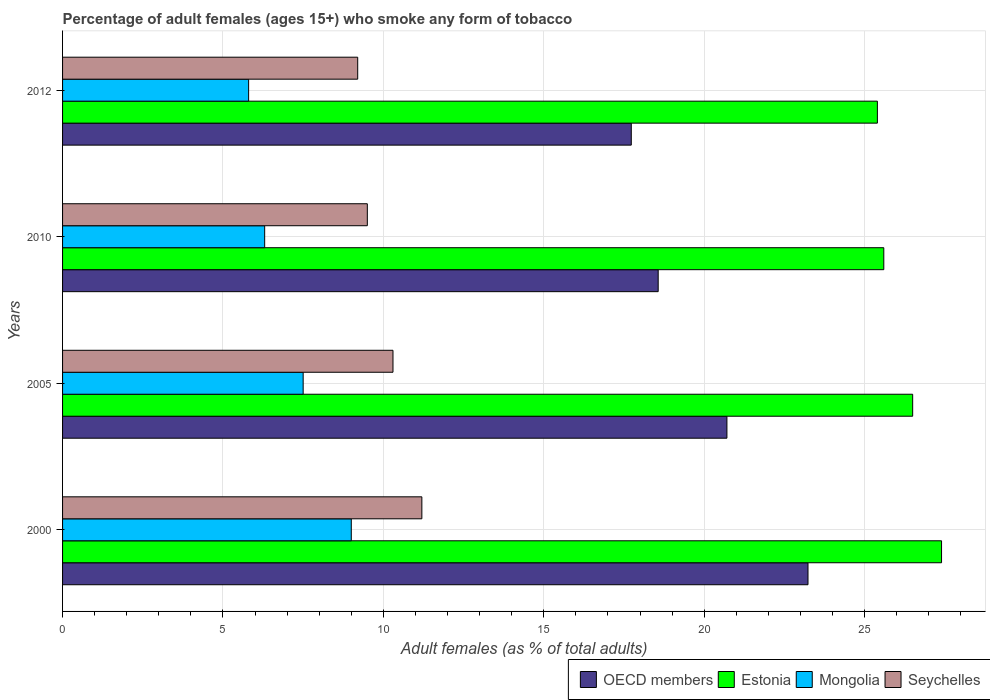How many different coloured bars are there?
Make the answer very short. 4. Are the number of bars on each tick of the Y-axis equal?
Your answer should be compact. Yes. How many bars are there on the 2nd tick from the top?
Your response must be concise. 4. What is the percentage of adult females who smoke in OECD members in 2012?
Your answer should be compact. 17.73. Across all years, what is the maximum percentage of adult females who smoke in OECD members?
Keep it short and to the point. 23.24. In which year was the percentage of adult females who smoke in Mongolia maximum?
Ensure brevity in your answer.  2000. What is the total percentage of adult females who smoke in Mongolia in the graph?
Your response must be concise. 28.6. What is the difference between the percentage of adult females who smoke in Estonia in 2005 and that in 2010?
Offer a terse response. 0.9. What is the average percentage of adult females who smoke in Mongolia per year?
Your response must be concise. 7.15. In the year 2010, what is the difference between the percentage of adult females who smoke in Seychelles and percentage of adult females who smoke in Estonia?
Provide a short and direct response. -16.1. What is the ratio of the percentage of adult females who smoke in OECD members in 2000 to that in 2010?
Your response must be concise. 1.25. Is the percentage of adult females who smoke in OECD members in 2000 less than that in 2012?
Provide a short and direct response. No. Is the difference between the percentage of adult females who smoke in Seychelles in 2000 and 2005 greater than the difference between the percentage of adult females who smoke in Estonia in 2000 and 2005?
Offer a terse response. No. What is the difference between the highest and the second highest percentage of adult females who smoke in OECD members?
Provide a succinct answer. 2.53. What is the difference between the highest and the lowest percentage of adult females who smoke in Estonia?
Offer a terse response. 2. In how many years, is the percentage of adult females who smoke in Mongolia greater than the average percentage of adult females who smoke in Mongolia taken over all years?
Provide a short and direct response. 2. What does the 2nd bar from the top in 2005 represents?
Offer a terse response. Mongolia. What does the 2nd bar from the bottom in 2010 represents?
Your answer should be compact. Estonia. Is it the case that in every year, the sum of the percentage of adult females who smoke in Mongolia and percentage of adult females who smoke in Seychelles is greater than the percentage of adult females who smoke in OECD members?
Give a very brief answer. No. How many bars are there?
Provide a short and direct response. 16. Are all the bars in the graph horizontal?
Give a very brief answer. Yes. How many years are there in the graph?
Give a very brief answer. 4. Are the values on the major ticks of X-axis written in scientific E-notation?
Your answer should be very brief. No. Does the graph contain grids?
Make the answer very short. Yes. How many legend labels are there?
Offer a very short reply. 4. What is the title of the graph?
Give a very brief answer. Percentage of adult females (ages 15+) who smoke any form of tobacco. Does "Uzbekistan" appear as one of the legend labels in the graph?
Provide a short and direct response. No. What is the label or title of the X-axis?
Provide a short and direct response. Adult females (as % of total adults). What is the Adult females (as % of total adults) in OECD members in 2000?
Offer a terse response. 23.24. What is the Adult females (as % of total adults) of Estonia in 2000?
Offer a very short reply. 27.4. What is the Adult females (as % of total adults) of Mongolia in 2000?
Your answer should be compact. 9. What is the Adult females (as % of total adults) in OECD members in 2005?
Provide a succinct answer. 20.71. What is the Adult females (as % of total adults) in Mongolia in 2005?
Offer a terse response. 7.5. What is the Adult females (as % of total adults) in Seychelles in 2005?
Ensure brevity in your answer.  10.3. What is the Adult females (as % of total adults) of OECD members in 2010?
Your answer should be very brief. 18.57. What is the Adult females (as % of total adults) in Estonia in 2010?
Offer a very short reply. 25.6. What is the Adult females (as % of total adults) in Mongolia in 2010?
Your answer should be compact. 6.3. What is the Adult females (as % of total adults) of OECD members in 2012?
Offer a very short reply. 17.73. What is the Adult females (as % of total adults) in Estonia in 2012?
Provide a succinct answer. 25.4. What is the Adult females (as % of total adults) of Mongolia in 2012?
Provide a succinct answer. 5.8. What is the Adult females (as % of total adults) of Seychelles in 2012?
Provide a succinct answer. 9.2. Across all years, what is the maximum Adult females (as % of total adults) in OECD members?
Your answer should be compact. 23.24. Across all years, what is the maximum Adult females (as % of total adults) of Estonia?
Offer a terse response. 27.4. Across all years, what is the maximum Adult females (as % of total adults) of Mongolia?
Your answer should be compact. 9. Across all years, what is the maximum Adult females (as % of total adults) of Seychelles?
Offer a terse response. 11.2. Across all years, what is the minimum Adult females (as % of total adults) in OECD members?
Keep it short and to the point. 17.73. Across all years, what is the minimum Adult females (as % of total adults) of Estonia?
Your answer should be very brief. 25.4. What is the total Adult females (as % of total adults) of OECD members in the graph?
Make the answer very short. 80.24. What is the total Adult females (as % of total adults) of Estonia in the graph?
Your answer should be compact. 104.9. What is the total Adult females (as % of total adults) in Mongolia in the graph?
Keep it short and to the point. 28.6. What is the total Adult females (as % of total adults) of Seychelles in the graph?
Your response must be concise. 40.2. What is the difference between the Adult females (as % of total adults) in OECD members in 2000 and that in 2005?
Ensure brevity in your answer.  2.53. What is the difference between the Adult females (as % of total adults) in Mongolia in 2000 and that in 2005?
Offer a terse response. 1.5. What is the difference between the Adult females (as % of total adults) in OECD members in 2000 and that in 2010?
Offer a very short reply. 4.67. What is the difference between the Adult females (as % of total adults) in Seychelles in 2000 and that in 2010?
Provide a succinct answer. 1.7. What is the difference between the Adult females (as % of total adults) of OECD members in 2000 and that in 2012?
Ensure brevity in your answer.  5.51. What is the difference between the Adult females (as % of total adults) of Seychelles in 2000 and that in 2012?
Give a very brief answer. 2. What is the difference between the Adult females (as % of total adults) of OECD members in 2005 and that in 2010?
Provide a short and direct response. 2.14. What is the difference between the Adult females (as % of total adults) in Mongolia in 2005 and that in 2010?
Give a very brief answer. 1.2. What is the difference between the Adult females (as % of total adults) in OECD members in 2005 and that in 2012?
Ensure brevity in your answer.  2.98. What is the difference between the Adult females (as % of total adults) in Seychelles in 2005 and that in 2012?
Keep it short and to the point. 1.1. What is the difference between the Adult females (as % of total adults) of OECD members in 2010 and that in 2012?
Ensure brevity in your answer.  0.84. What is the difference between the Adult females (as % of total adults) in Seychelles in 2010 and that in 2012?
Offer a very short reply. 0.3. What is the difference between the Adult females (as % of total adults) in OECD members in 2000 and the Adult females (as % of total adults) in Estonia in 2005?
Provide a succinct answer. -3.26. What is the difference between the Adult females (as % of total adults) of OECD members in 2000 and the Adult females (as % of total adults) of Mongolia in 2005?
Give a very brief answer. 15.74. What is the difference between the Adult females (as % of total adults) in OECD members in 2000 and the Adult females (as % of total adults) in Seychelles in 2005?
Your answer should be compact. 12.94. What is the difference between the Adult females (as % of total adults) of Estonia in 2000 and the Adult females (as % of total adults) of Mongolia in 2005?
Make the answer very short. 19.9. What is the difference between the Adult females (as % of total adults) of Estonia in 2000 and the Adult females (as % of total adults) of Seychelles in 2005?
Offer a terse response. 17.1. What is the difference between the Adult females (as % of total adults) in Mongolia in 2000 and the Adult females (as % of total adults) in Seychelles in 2005?
Provide a succinct answer. -1.3. What is the difference between the Adult females (as % of total adults) in OECD members in 2000 and the Adult females (as % of total adults) in Estonia in 2010?
Provide a succinct answer. -2.36. What is the difference between the Adult females (as % of total adults) of OECD members in 2000 and the Adult females (as % of total adults) of Mongolia in 2010?
Provide a succinct answer. 16.94. What is the difference between the Adult females (as % of total adults) of OECD members in 2000 and the Adult females (as % of total adults) of Seychelles in 2010?
Keep it short and to the point. 13.74. What is the difference between the Adult females (as % of total adults) in Estonia in 2000 and the Adult females (as % of total adults) in Mongolia in 2010?
Your answer should be compact. 21.1. What is the difference between the Adult females (as % of total adults) of Estonia in 2000 and the Adult females (as % of total adults) of Seychelles in 2010?
Offer a terse response. 17.9. What is the difference between the Adult females (as % of total adults) in Mongolia in 2000 and the Adult females (as % of total adults) in Seychelles in 2010?
Ensure brevity in your answer.  -0.5. What is the difference between the Adult females (as % of total adults) of OECD members in 2000 and the Adult females (as % of total adults) of Estonia in 2012?
Give a very brief answer. -2.16. What is the difference between the Adult females (as % of total adults) of OECD members in 2000 and the Adult females (as % of total adults) of Mongolia in 2012?
Provide a short and direct response. 17.44. What is the difference between the Adult females (as % of total adults) of OECD members in 2000 and the Adult females (as % of total adults) of Seychelles in 2012?
Make the answer very short. 14.04. What is the difference between the Adult females (as % of total adults) in Estonia in 2000 and the Adult females (as % of total adults) in Mongolia in 2012?
Your response must be concise. 21.6. What is the difference between the Adult females (as % of total adults) of Estonia in 2000 and the Adult females (as % of total adults) of Seychelles in 2012?
Offer a very short reply. 18.2. What is the difference between the Adult females (as % of total adults) in Mongolia in 2000 and the Adult females (as % of total adults) in Seychelles in 2012?
Make the answer very short. -0.2. What is the difference between the Adult females (as % of total adults) in OECD members in 2005 and the Adult females (as % of total adults) in Estonia in 2010?
Ensure brevity in your answer.  -4.89. What is the difference between the Adult females (as % of total adults) of OECD members in 2005 and the Adult females (as % of total adults) of Mongolia in 2010?
Provide a short and direct response. 14.41. What is the difference between the Adult females (as % of total adults) of OECD members in 2005 and the Adult females (as % of total adults) of Seychelles in 2010?
Give a very brief answer. 11.21. What is the difference between the Adult females (as % of total adults) in Estonia in 2005 and the Adult females (as % of total adults) in Mongolia in 2010?
Your answer should be very brief. 20.2. What is the difference between the Adult females (as % of total adults) of Mongolia in 2005 and the Adult females (as % of total adults) of Seychelles in 2010?
Provide a short and direct response. -2. What is the difference between the Adult females (as % of total adults) of OECD members in 2005 and the Adult females (as % of total adults) of Estonia in 2012?
Ensure brevity in your answer.  -4.69. What is the difference between the Adult females (as % of total adults) in OECD members in 2005 and the Adult females (as % of total adults) in Mongolia in 2012?
Keep it short and to the point. 14.91. What is the difference between the Adult females (as % of total adults) in OECD members in 2005 and the Adult females (as % of total adults) in Seychelles in 2012?
Your response must be concise. 11.51. What is the difference between the Adult females (as % of total adults) of Estonia in 2005 and the Adult females (as % of total adults) of Mongolia in 2012?
Provide a short and direct response. 20.7. What is the difference between the Adult females (as % of total adults) in Mongolia in 2005 and the Adult females (as % of total adults) in Seychelles in 2012?
Provide a short and direct response. -1.7. What is the difference between the Adult females (as % of total adults) in OECD members in 2010 and the Adult females (as % of total adults) in Estonia in 2012?
Give a very brief answer. -6.83. What is the difference between the Adult females (as % of total adults) of OECD members in 2010 and the Adult females (as % of total adults) of Mongolia in 2012?
Keep it short and to the point. 12.77. What is the difference between the Adult females (as % of total adults) in OECD members in 2010 and the Adult females (as % of total adults) in Seychelles in 2012?
Offer a terse response. 9.37. What is the difference between the Adult females (as % of total adults) of Estonia in 2010 and the Adult females (as % of total adults) of Mongolia in 2012?
Provide a short and direct response. 19.8. What is the difference between the Adult females (as % of total adults) in Estonia in 2010 and the Adult females (as % of total adults) in Seychelles in 2012?
Offer a terse response. 16.4. What is the average Adult females (as % of total adults) of OECD members per year?
Your answer should be compact. 20.06. What is the average Adult females (as % of total adults) of Estonia per year?
Ensure brevity in your answer.  26.23. What is the average Adult females (as % of total adults) of Mongolia per year?
Keep it short and to the point. 7.15. What is the average Adult females (as % of total adults) in Seychelles per year?
Keep it short and to the point. 10.05. In the year 2000, what is the difference between the Adult females (as % of total adults) in OECD members and Adult females (as % of total adults) in Estonia?
Ensure brevity in your answer.  -4.16. In the year 2000, what is the difference between the Adult females (as % of total adults) of OECD members and Adult females (as % of total adults) of Mongolia?
Ensure brevity in your answer.  14.24. In the year 2000, what is the difference between the Adult females (as % of total adults) in OECD members and Adult females (as % of total adults) in Seychelles?
Provide a succinct answer. 12.04. In the year 2000, what is the difference between the Adult females (as % of total adults) in Estonia and Adult females (as % of total adults) in Seychelles?
Your answer should be very brief. 16.2. In the year 2005, what is the difference between the Adult females (as % of total adults) in OECD members and Adult females (as % of total adults) in Estonia?
Your answer should be very brief. -5.79. In the year 2005, what is the difference between the Adult females (as % of total adults) in OECD members and Adult females (as % of total adults) in Mongolia?
Provide a succinct answer. 13.21. In the year 2005, what is the difference between the Adult females (as % of total adults) in OECD members and Adult females (as % of total adults) in Seychelles?
Your answer should be compact. 10.41. In the year 2005, what is the difference between the Adult females (as % of total adults) of Estonia and Adult females (as % of total adults) of Mongolia?
Provide a succinct answer. 19. In the year 2005, what is the difference between the Adult females (as % of total adults) in Estonia and Adult females (as % of total adults) in Seychelles?
Offer a terse response. 16.2. In the year 2010, what is the difference between the Adult females (as % of total adults) of OECD members and Adult females (as % of total adults) of Estonia?
Keep it short and to the point. -7.03. In the year 2010, what is the difference between the Adult females (as % of total adults) of OECD members and Adult females (as % of total adults) of Mongolia?
Ensure brevity in your answer.  12.27. In the year 2010, what is the difference between the Adult females (as % of total adults) in OECD members and Adult females (as % of total adults) in Seychelles?
Your answer should be compact. 9.07. In the year 2010, what is the difference between the Adult females (as % of total adults) in Estonia and Adult females (as % of total adults) in Mongolia?
Offer a very short reply. 19.3. In the year 2012, what is the difference between the Adult females (as % of total adults) of OECD members and Adult females (as % of total adults) of Estonia?
Your answer should be compact. -7.67. In the year 2012, what is the difference between the Adult females (as % of total adults) of OECD members and Adult females (as % of total adults) of Mongolia?
Provide a short and direct response. 11.93. In the year 2012, what is the difference between the Adult females (as % of total adults) in OECD members and Adult females (as % of total adults) in Seychelles?
Your answer should be compact. 8.53. In the year 2012, what is the difference between the Adult females (as % of total adults) of Estonia and Adult females (as % of total adults) of Mongolia?
Your response must be concise. 19.6. In the year 2012, what is the difference between the Adult females (as % of total adults) of Estonia and Adult females (as % of total adults) of Seychelles?
Give a very brief answer. 16.2. In the year 2012, what is the difference between the Adult females (as % of total adults) of Mongolia and Adult females (as % of total adults) of Seychelles?
Give a very brief answer. -3.4. What is the ratio of the Adult females (as % of total adults) in OECD members in 2000 to that in 2005?
Provide a short and direct response. 1.12. What is the ratio of the Adult females (as % of total adults) in Estonia in 2000 to that in 2005?
Provide a short and direct response. 1.03. What is the ratio of the Adult females (as % of total adults) in Mongolia in 2000 to that in 2005?
Provide a short and direct response. 1.2. What is the ratio of the Adult females (as % of total adults) of Seychelles in 2000 to that in 2005?
Your answer should be compact. 1.09. What is the ratio of the Adult females (as % of total adults) in OECD members in 2000 to that in 2010?
Provide a short and direct response. 1.25. What is the ratio of the Adult females (as % of total adults) of Estonia in 2000 to that in 2010?
Offer a very short reply. 1.07. What is the ratio of the Adult females (as % of total adults) of Mongolia in 2000 to that in 2010?
Offer a terse response. 1.43. What is the ratio of the Adult females (as % of total adults) of Seychelles in 2000 to that in 2010?
Provide a short and direct response. 1.18. What is the ratio of the Adult females (as % of total adults) in OECD members in 2000 to that in 2012?
Offer a very short reply. 1.31. What is the ratio of the Adult females (as % of total adults) in Estonia in 2000 to that in 2012?
Provide a short and direct response. 1.08. What is the ratio of the Adult females (as % of total adults) of Mongolia in 2000 to that in 2012?
Keep it short and to the point. 1.55. What is the ratio of the Adult females (as % of total adults) of Seychelles in 2000 to that in 2012?
Provide a succinct answer. 1.22. What is the ratio of the Adult females (as % of total adults) in OECD members in 2005 to that in 2010?
Keep it short and to the point. 1.12. What is the ratio of the Adult females (as % of total adults) of Estonia in 2005 to that in 2010?
Offer a very short reply. 1.04. What is the ratio of the Adult females (as % of total adults) of Mongolia in 2005 to that in 2010?
Offer a very short reply. 1.19. What is the ratio of the Adult females (as % of total adults) of Seychelles in 2005 to that in 2010?
Offer a very short reply. 1.08. What is the ratio of the Adult females (as % of total adults) of OECD members in 2005 to that in 2012?
Give a very brief answer. 1.17. What is the ratio of the Adult females (as % of total adults) of Estonia in 2005 to that in 2012?
Ensure brevity in your answer.  1.04. What is the ratio of the Adult females (as % of total adults) in Mongolia in 2005 to that in 2012?
Your response must be concise. 1.29. What is the ratio of the Adult females (as % of total adults) of Seychelles in 2005 to that in 2012?
Ensure brevity in your answer.  1.12. What is the ratio of the Adult females (as % of total adults) in OECD members in 2010 to that in 2012?
Your response must be concise. 1.05. What is the ratio of the Adult females (as % of total adults) in Estonia in 2010 to that in 2012?
Offer a terse response. 1.01. What is the ratio of the Adult females (as % of total adults) of Mongolia in 2010 to that in 2012?
Keep it short and to the point. 1.09. What is the ratio of the Adult females (as % of total adults) in Seychelles in 2010 to that in 2012?
Offer a very short reply. 1.03. What is the difference between the highest and the second highest Adult females (as % of total adults) of OECD members?
Offer a terse response. 2.53. What is the difference between the highest and the second highest Adult females (as % of total adults) of Mongolia?
Your answer should be compact. 1.5. What is the difference between the highest and the lowest Adult females (as % of total adults) of OECD members?
Provide a short and direct response. 5.51. What is the difference between the highest and the lowest Adult females (as % of total adults) in Estonia?
Offer a very short reply. 2. What is the difference between the highest and the lowest Adult females (as % of total adults) in Mongolia?
Give a very brief answer. 3.2. What is the difference between the highest and the lowest Adult females (as % of total adults) in Seychelles?
Make the answer very short. 2. 